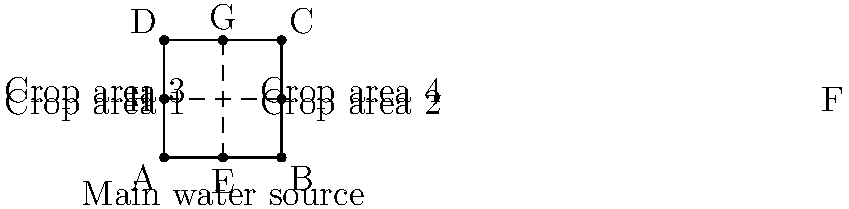Given the schematic diagram of your botanical farm layout, which irrigation system configuration would be most efficient for distributing water evenly to all four crop areas while minimizing water waste and energy consumption? To determine the most efficient irrigation system layout, we need to consider the following factors:

1. Water distribution: The system should provide equal access to water for all four crop areas.
2. Pipe length: Shorter total pipe length reduces water loss and energy consumption.
3. Pressure distribution: A balanced layout ensures even water pressure throughout the system.

Analyzing the diagram:

1. The main water source is located at the center of the bottom edge (point E).
2. The farm is divided into four equal crop areas by the dashed lines.

The most efficient layout would be:

1. Start with a main pipeline from the water source (E) to the center of the farm (intersection of EG and HF).
2. From the center, branch out four equal-length pipes to the centers of each crop area.

This configuration provides:

1. Equal water distribution to all four crop areas.
2. Minimal total pipe length, reducing water loss and energy consumption.
3. Balanced pressure distribution due to symmetrical layout.
4. Flexibility for installing drip irrigation or sprinkler systems within each crop area.

The resulting layout resembles a "+" shape, with the main line running from E to G and secondary lines branching out to the centers of each crop area.
Answer: "+"-shaped layout with main line E to G and four equal branches to crop centers 